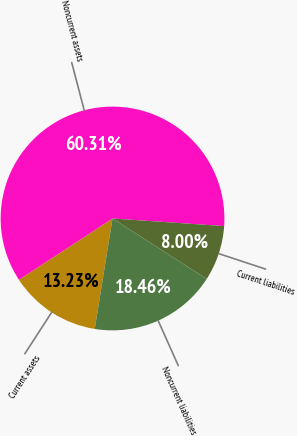<chart> <loc_0><loc_0><loc_500><loc_500><pie_chart><fcel>Current assets<fcel>Noncurrent assets<fcel>Current liabilities<fcel>Noncurrent liabilities<nl><fcel>13.23%<fcel>60.31%<fcel>8.0%<fcel>18.46%<nl></chart> 